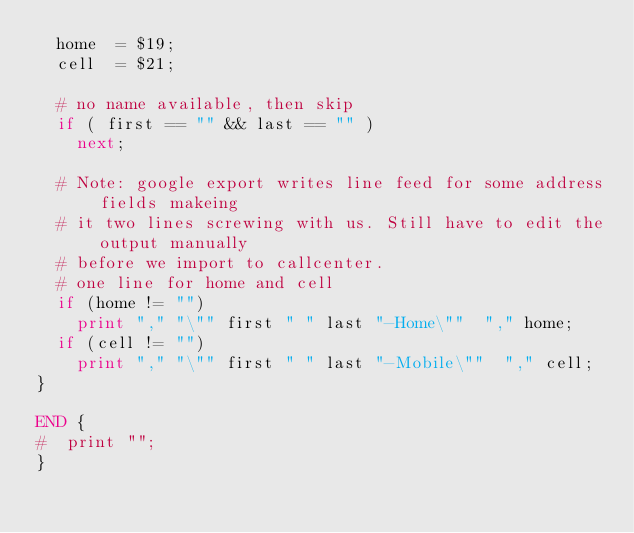Convert code to text. <code><loc_0><loc_0><loc_500><loc_500><_Awk_>  home  = $19;
  cell  = $21;

  # no name available, then skip
  if ( first == "" && last == "" ) 
    next;
    
  # Note: google export writes line feed for some address fields makeing
  # it two lines screwing with us. Still have to edit the output manually
  # before we import to callcenter.
  # one line for home and cell 
  if (home != "") 
    print "," "\"" first " " last "-Home\""  "," home;
  if (cell != "")
    print "," "\"" first " " last "-Mobile\""  "," cell;
}

END {
#  print "";
}

</code> 